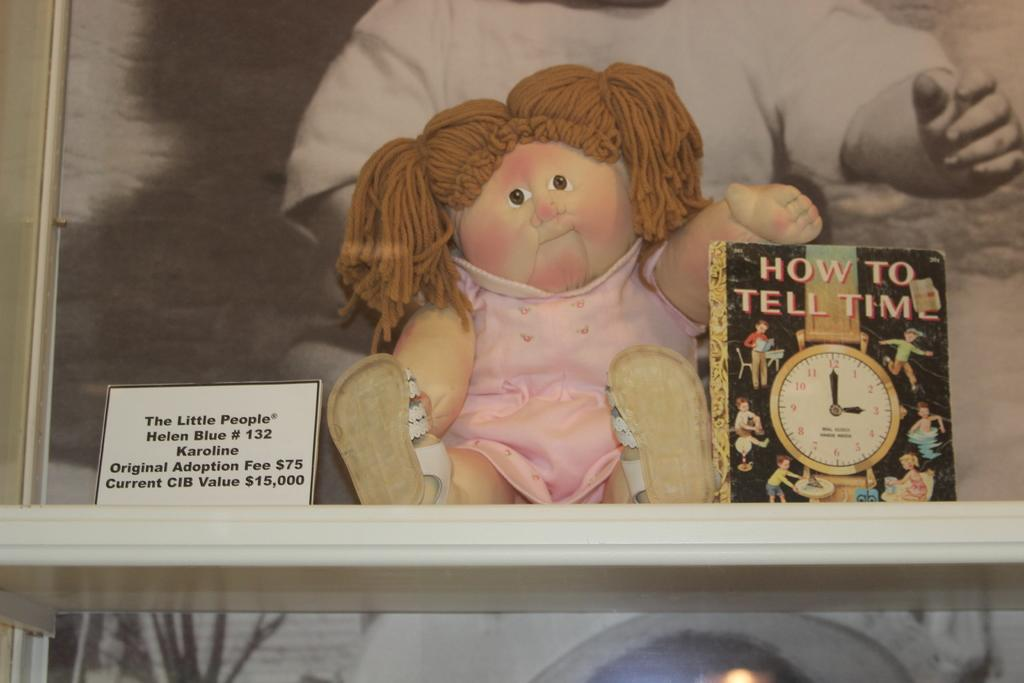Provide a one-sentence caption for the provided image. A girl doll sits on a shelf holding the book "How To Tell Time". 